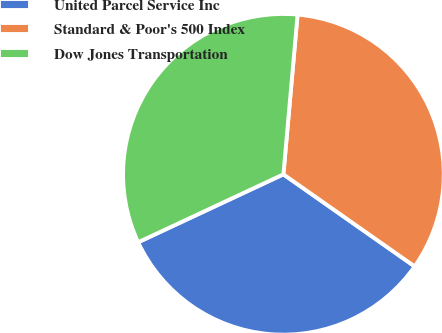<chart> <loc_0><loc_0><loc_500><loc_500><pie_chart><fcel>United Parcel Service Inc<fcel>Standard & Poor's 500 Index<fcel>Dow Jones Transportation<nl><fcel>33.3%<fcel>33.33%<fcel>33.37%<nl></chart> 